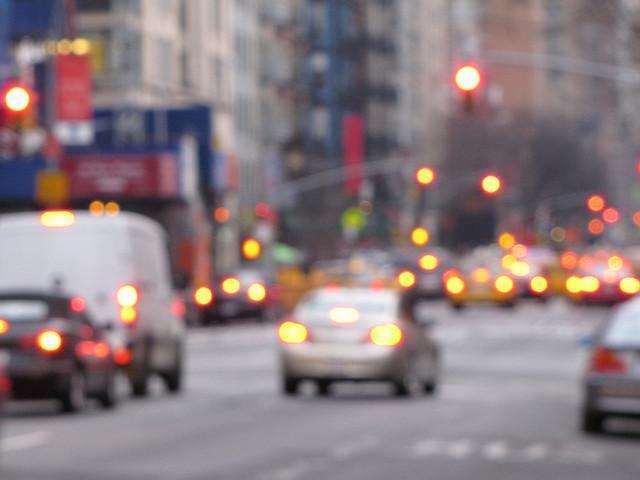How many cars are in the picture?
Give a very brief answer. 6. 